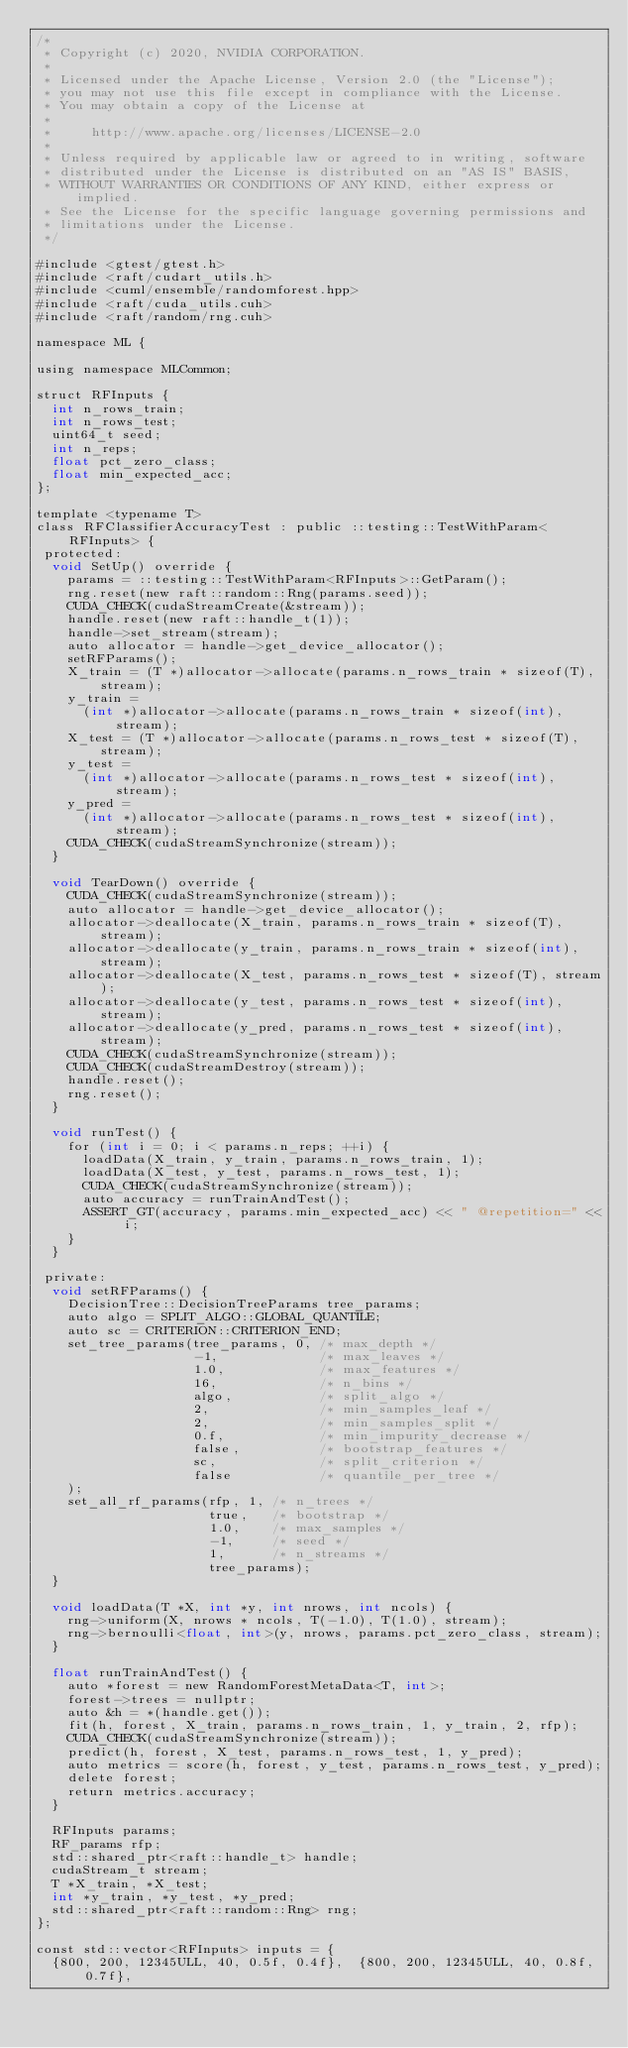<code> <loc_0><loc_0><loc_500><loc_500><_Cuda_>/*
 * Copyright (c) 2020, NVIDIA CORPORATION.
 *
 * Licensed under the Apache License, Version 2.0 (the "License");
 * you may not use this file except in compliance with the License.
 * You may obtain a copy of the License at
 *
 *     http://www.apache.org/licenses/LICENSE-2.0
 *
 * Unless required by applicable law or agreed to in writing, software
 * distributed under the License is distributed on an "AS IS" BASIS,
 * WITHOUT WARRANTIES OR CONDITIONS OF ANY KIND, either express or implied.
 * See the License for the specific language governing permissions and
 * limitations under the License.
 */

#include <gtest/gtest.h>
#include <raft/cudart_utils.h>
#include <cuml/ensemble/randomforest.hpp>
#include <raft/cuda_utils.cuh>
#include <raft/random/rng.cuh>

namespace ML {

using namespace MLCommon;

struct RFInputs {
  int n_rows_train;
  int n_rows_test;
  uint64_t seed;
  int n_reps;
  float pct_zero_class;
  float min_expected_acc;
};

template <typename T>
class RFClassifierAccuracyTest : public ::testing::TestWithParam<RFInputs> {
 protected:
  void SetUp() override {
    params = ::testing::TestWithParam<RFInputs>::GetParam();
    rng.reset(new raft::random::Rng(params.seed));
    CUDA_CHECK(cudaStreamCreate(&stream));
    handle.reset(new raft::handle_t(1));
    handle->set_stream(stream);
    auto allocator = handle->get_device_allocator();
    setRFParams();
    X_train = (T *)allocator->allocate(params.n_rows_train * sizeof(T), stream);
    y_train =
      (int *)allocator->allocate(params.n_rows_train * sizeof(int), stream);
    X_test = (T *)allocator->allocate(params.n_rows_test * sizeof(T), stream);
    y_test =
      (int *)allocator->allocate(params.n_rows_test * sizeof(int), stream);
    y_pred =
      (int *)allocator->allocate(params.n_rows_test * sizeof(int), stream);
    CUDA_CHECK(cudaStreamSynchronize(stream));
  }

  void TearDown() override {
    CUDA_CHECK(cudaStreamSynchronize(stream));
    auto allocator = handle->get_device_allocator();
    allocator->deallocate(X_train, params.n_rows_train * sizeof(T), stream);
    allocator->deallocate(y_train, params.n_rows_train * sizeof(int), stream);
    allocator->deallocate(X_test, params.n_rows_test * sizeof(T), stream);
    allocator->deallocate(y_test, params.n_rows_test * sizeof(int), stream);
    allocator->deallocate(y_pred, params.n_rows_test * sizeof(int), stream);
    CUDA_CHECK(cudaStreamSynchronize(stream));
    CUDA_CHECK(cudaStreamDestroy(stream));
    handle.reset();
    rng.reset();
  }

  void runTest() {
    for (int i = 0; i < params.n_reps; ++i) {
      loadData(X_train, y_train, params.n_rows_train, 1);
      loadData(X_test, y_test, params.n_rows_test, 1);
      CUDA_CHECK(cudaStreamSynchronize(stream));
      auto accuracy = runTrainAndTest();
      ASSERT_GT(accuracy, params.min_expected_acc) << " @repetition=" << i;
    }
  }

 private:
  void setRFParams() {
    DecisionTree::DecisionTreeParams tree_params;
    auto algo = SPLIT_ALGO::GLOBAL_QUANTILE;
    auto sc = CRITERION::CRITERION_END;
    set_tree_params(tree_params, 0, /* max_depth */
                    -1,             /* max_leaves */
                    1.0,            /* max_features */
                    16,             /* n_bins */
                    algo,           /* split_algo */
                    2,              /* min_samples_leaf */
                    2,              /* min_samples_split */
                    0.f,            /* min_impurity_decrease */
                    false,          /* bootstrap_features */
                    sc,             /* split_criterion */
                    false           /* quantile_per_tree */
    );
    set_all_rf_params(rfp, 1, /* n_trees */
                      true,   /* bootstrap */
                      1.0,    /* max_samples */
                      -1,     /* seed */
                      1,      /* n_streams */
                      tree_params);
  }

  void loadData(T *X, int *y, int nrows, int ncols) {
    rng->uniform(X, nrows * ncols, T(-1.0), T(1.0), stream);
    rng->bernoulli<float, int>(y, nrows, params.pct_zero_class, stream);
  }

  float runTrainAndTest() {
    auto *forest = new RandomForestMetaData<T, int>;
    forest->trees = nullptr;
    auto &h = *(handle.get());
    fit(h, forest, X_train, params.n_rows_train, 1, y_train, 2, rfp);
    CUDA_CHECK(cudaStreamSynchronize(stream));
    predict(h, forest, X_test, params.n_rows_test, 1, y_pred);
    auto metrics = score(h, forest, y_test, params.n_rows_test, y_pred);
    delete forest;
    return metrics.accuracy;
  }

  RFInputs params;
  RF_params rfp;
  std::shared_ptr<raft::handle_t> handle;
  cudaStream_t stream;
  T *X_train, *X_test;
  int *y_train, *y_test, *y_pred;
  std::shared_ptr<raft::random::Rng> rng;
};

const std::vector<RFInputs> inputs = {
  {800, 200, 12345ULL, 40, 0.5f, 0.4f},  {800, 200, 12345ULL, 40, 0.8f, 0.7f},</code> 